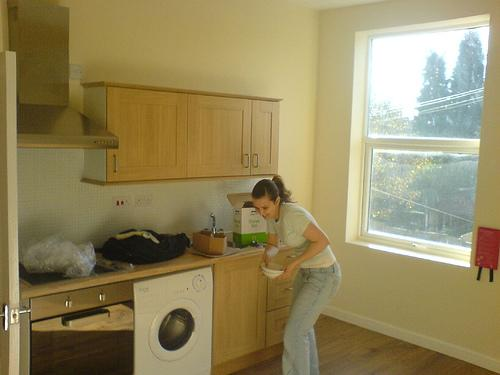What is the woman using the bowl for here? feed pet 